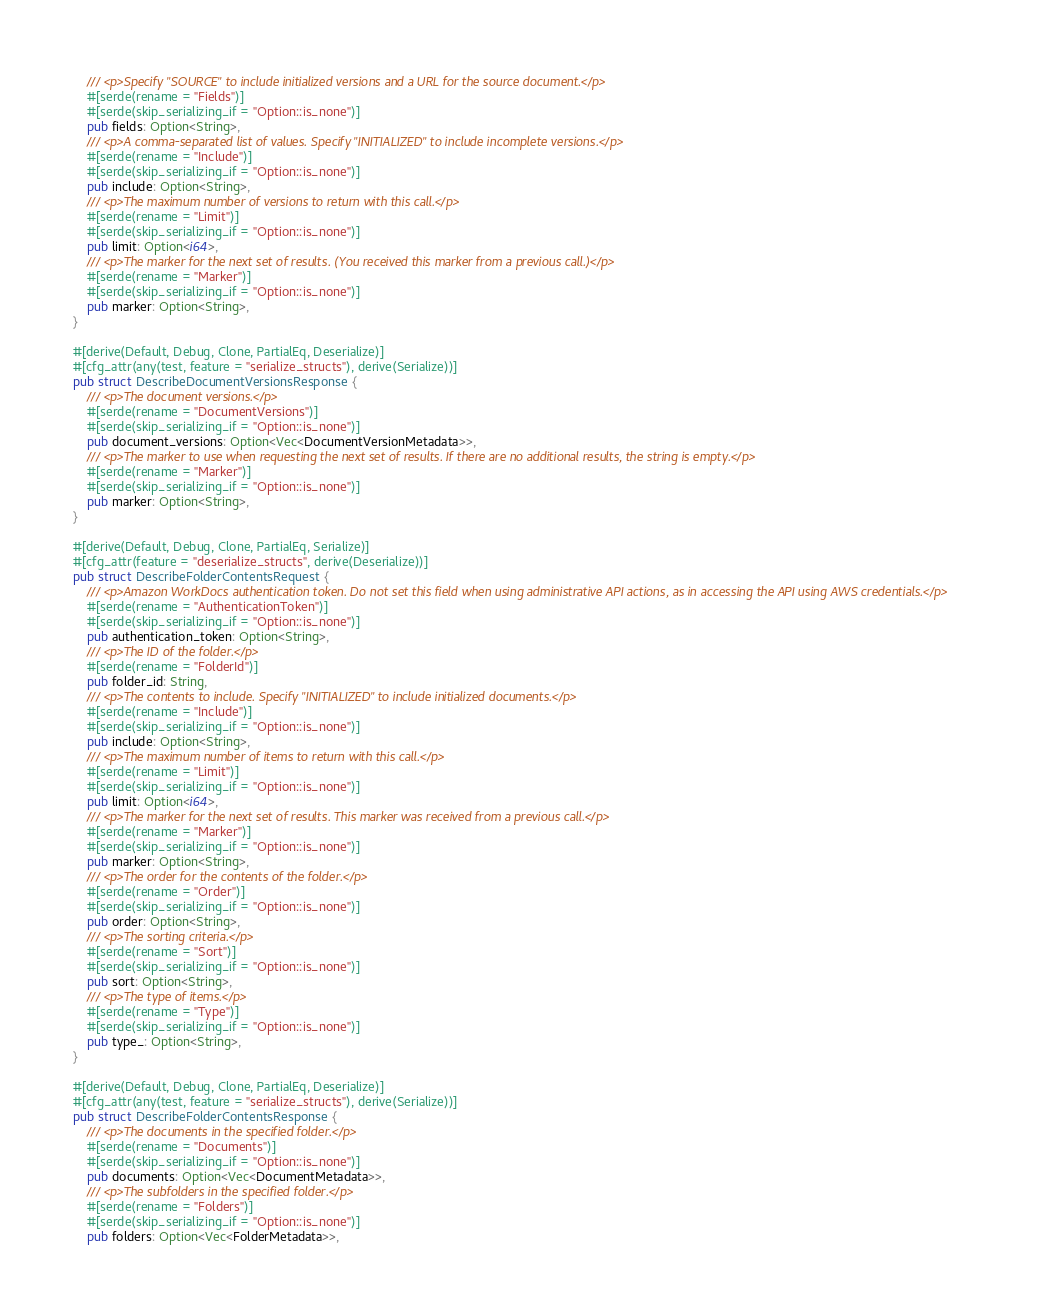<code> <loc_0><loc_0><loc_500><loc_500><_Rust_>    /// <p>Specify "SOURCE" to include initialized versions and a URL for the source document.</p>
    #[serde(rename = "Fields")]
    #[serde(skip_serializing_if = "Option::is_none")]
    pub fields: Option<String>,
    /// <p>A comma-separated list of values. Specify "INITIALIZED" to include incomplete versions.</p>
    #[serde(rename = "Include")]
    #[serde(skip_serializing_if = "Option::is_none")]
    pub include: Option<String>,
    /// <p>The maximum number of versions to return with this call.</p>
    #[serde(rename = "Limit")]
    #[serde(skip_serializing_if = "Option::is_none")]
    pub limit: Option<i64>,
    /// <p>The marker for the next set of results. (You received this marker from a previous call.)</p>
    #[serde(rename = "Marker")]
    #[serde(skip_serializing_if = "Option::is_none")]
    pub marker: Option<String>,
}

#[derive(Default, Debug, Clone, PartialEq, Deserialize)]
#[cfg_attr(any(test, feature = "serialize_structs"), derive(Serialize))]
pub struct DescribeDocumentVersionsResponse {
    /// <p>The document versions.</p>
    #[serde(rename = "DocumentVersions")]
    #[serde(skip_serializing_if = "Option::is_none")]
    pub document_versions: Option<Vec<DocumentVersionMetadata>>,
    /// <p>The marker to use when requesting the next set of results. If there are no additional results, the string is empty.</p>
    #[serde(rename = "Marker")]
    #[serde(skip_serializing_if = "Option::is_none")]
    pub marker: Option<String>,
}

#[derive(Default, Debug, Clone, PartialEq, Serialize)]
#[cfg_attr(feature = "deserialize_structs", derive(Deserialize))]
pub struct DescribeFolderContentsRequest {
    /// <p>Amazon WorkDocs authentication token. Do not set this field when using administrative API actions, as in accessing the API using AWS credentials.</p>
    #[serde(rename = "AuthenticationToken")]
    #[serde(skip_serializing_if = "Option::is_none")]
    pub authentication_token: Option<String>,
    /// <p>The ID of the folder.</p>
    #[serde(rename = "FolderId")]
    pub folder_id: String,
    /// <p>The contents to include. Specify "INITIALIZED" to include initialized documents.</p>
    #[serde(rename = "Include")]
    #[serde(skip_serializing_if = "Option::is_none")]
    pub include: Option<String>,
    /// <p>The maximum number of items to return with this call.</p>
    #[serde(rename = "Limit")]
    #[serde(skip_serializing_if = "Option::is_none")]
    pub limit: Option<i64>,
    /// <p>The marker for the next set of results. This marker was received from a previous call.</p>
    #[serde(rename = "Marker")]
    #[serde(skip_serializing_if = "Option::is_none")]
    pub marker: Option<String>,
    /// <p>The order for the contents of the folder.</p>
    #[serde(rename = "Order")]
    #[serde(skip_serializing_if = "Option::is_none")]
    pub order: Option<String>,
    /// <p>The sorting criteria.</p>
    #[serde(rename = "Sort")]
    #[serde(skip_serializing_if = "Option::is_none")]
    pub sort: Option<String>,
    /// <p>The type of items.</p>
    #[serde(rename = "Type")]
    #[serde(skip_serializing_if = "Option::is_none")]
    pub type_: Option<String>,
}

#[derive(Default, Debug, Clone, PartialEq, Deserialize)]
#[cfg_attr(any(test, feature = "serialize_structs"), derive(Serialize))]
pub struct DescribeFolderContentsResponse {
    /// <p>The documents in the specified folder.</p>
    #[serde(rename = "Documents")]
    #[serde(skip_serializing_if = "Option::is_none")]
    pub documents: Option<Vec<DocumentMetadata>>,
    /// <p>The subfolders in the specified folder.</p>
    #[serde(rename = "Folders")]
    #[serde(skip_serializing_if = "Option::is_none")]
    pub folders: Option<Vec<FolderMetadata>>,</code> 